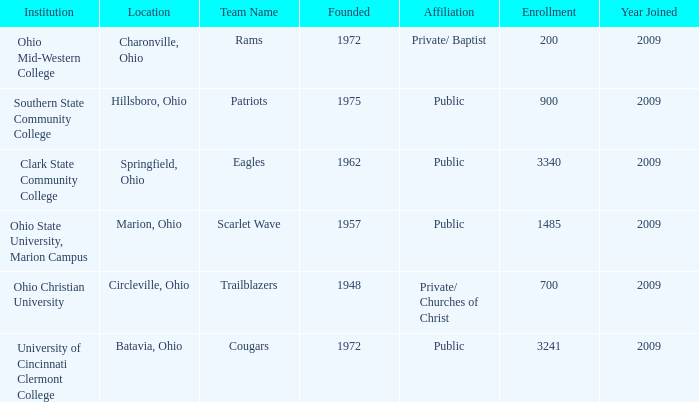What is the affiliation when the institution was ohio christian university? Private/ Churches of Christ. 